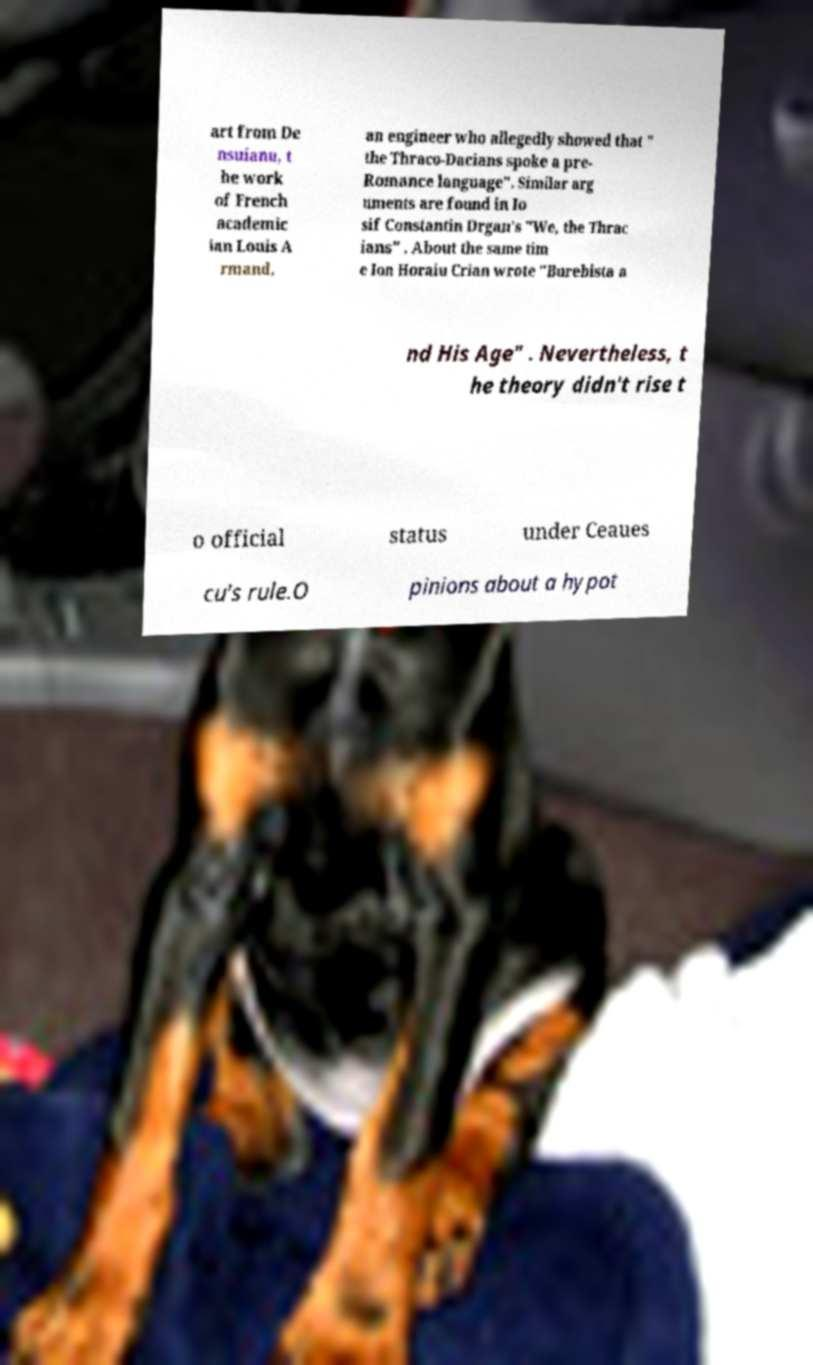I need the written content from this picture converted into text. Can you do that? art from De nsuianu, t he work of French academic ian Louis A rmand, an engineer who allegedly showed that " the Thraco-Dacians spoke a pre- Romance language". Similar arg uments are found in Io sif Constantin Drgan's "We, the Thrac ians" . About the same tim e Ion Horaiu Crian wrote "Burebista a nd His Age" . Nevertheless, t he theory didn't rise t o official status under Ceaues cu's rule.O pinions about a hypot 